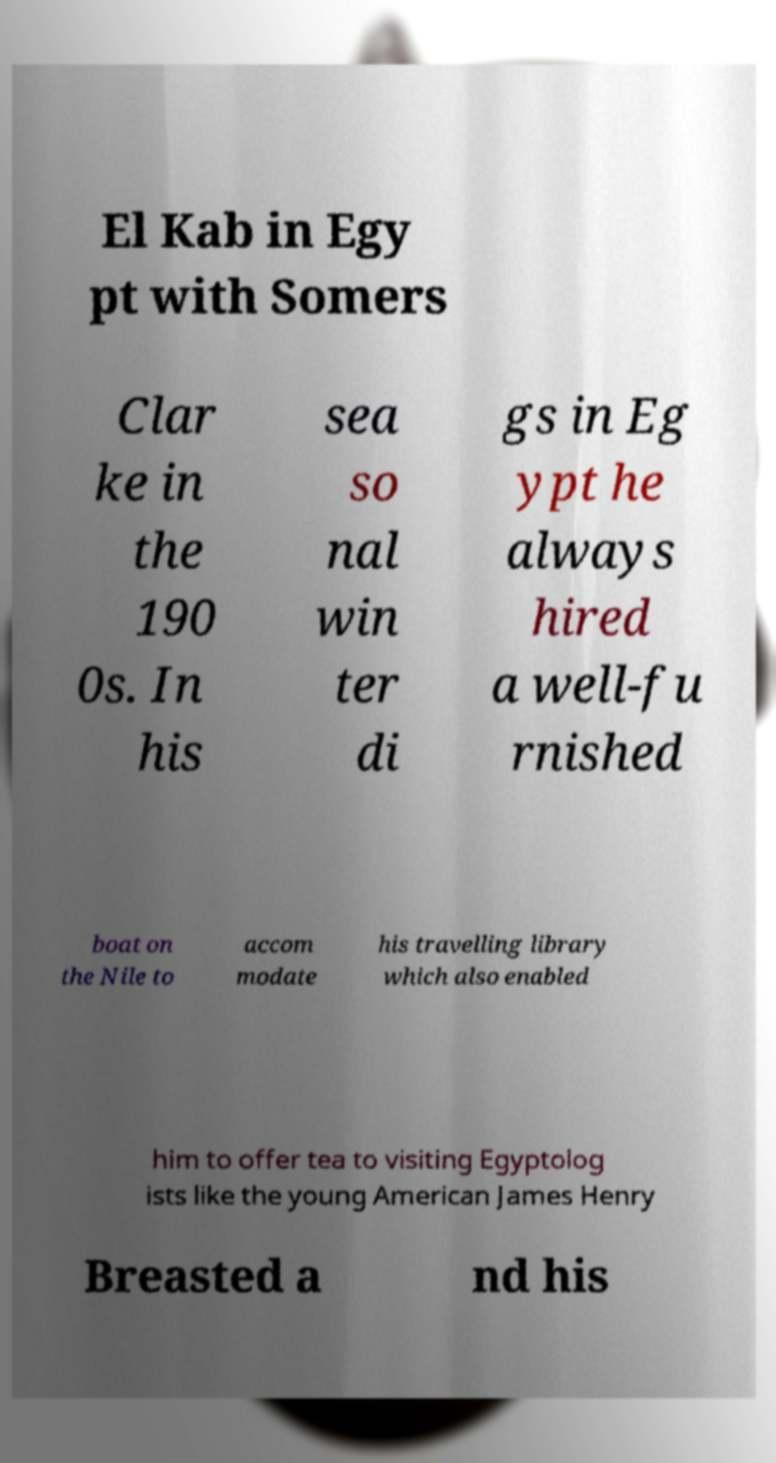I need the written content from this picture converted into text. Can you do that? El Kab in Egy pt with Somers Clar ke in the 190 0s. In his sea so nal win ter di gs in Eg ypt he always hired a well-fu rnished boat on the Nile to accom modate his travelling library which also enabled him to offer tea to visiting Egyptolog ists like the young American James Henry Breasted a nd his 